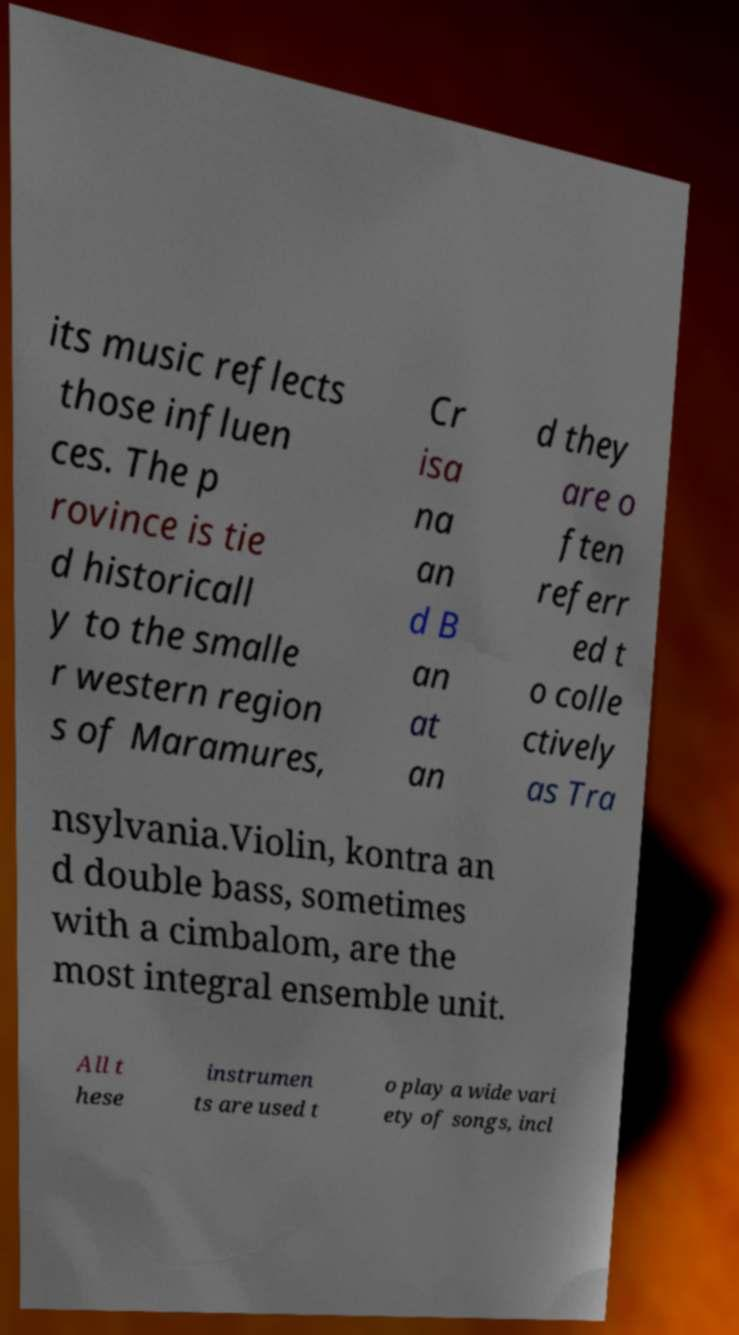Can you read and provide the text displayed in the image?This photo seems to have some interesting text. Can you extract and type it out for me? its music reflects those influen ces. The p rovince is tie d historicall y to the smalle r western region s of Maramures, Cr isa na an d B an at an d they are o ften referr ed t o colle ctively as Tra nsylvania.Violin, kontra an d double bass, sometimes with a cimbalom, are the most integral ensemble unit. All t hese instrumen ts are used t o play a wide vari ety of songs, incl 